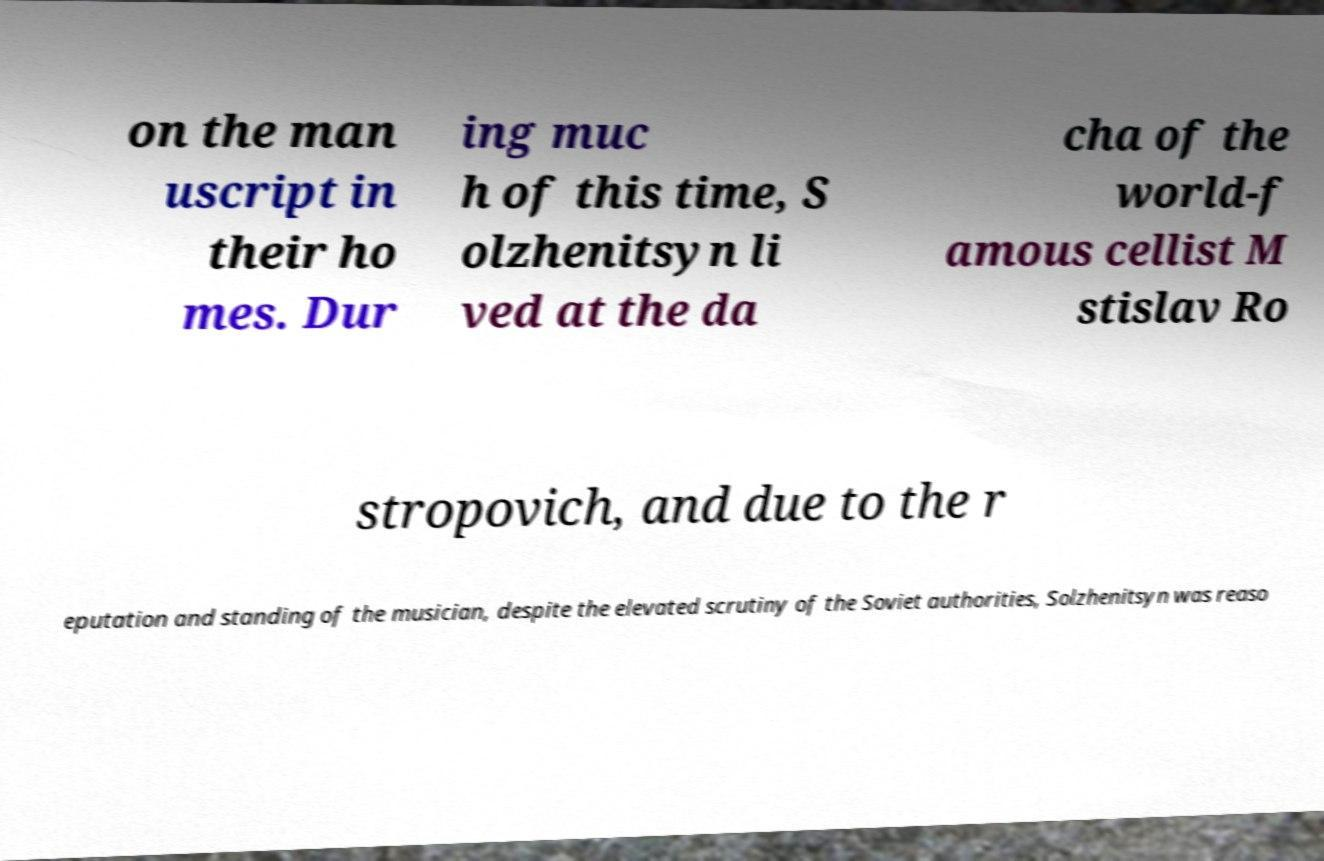Please read and relay the text visible in this image. What does it say? on the man uscript in their ho mes. Dur ing muc h of this time, S olzhenitsyn li ved at the da cha of the world-f amous cellist M stislav Ro stropovich, and due to the r eputation and standing of the musician, despite the elevated scrutiny of the Soviet authorities, Solzhenitsyn was reaso 